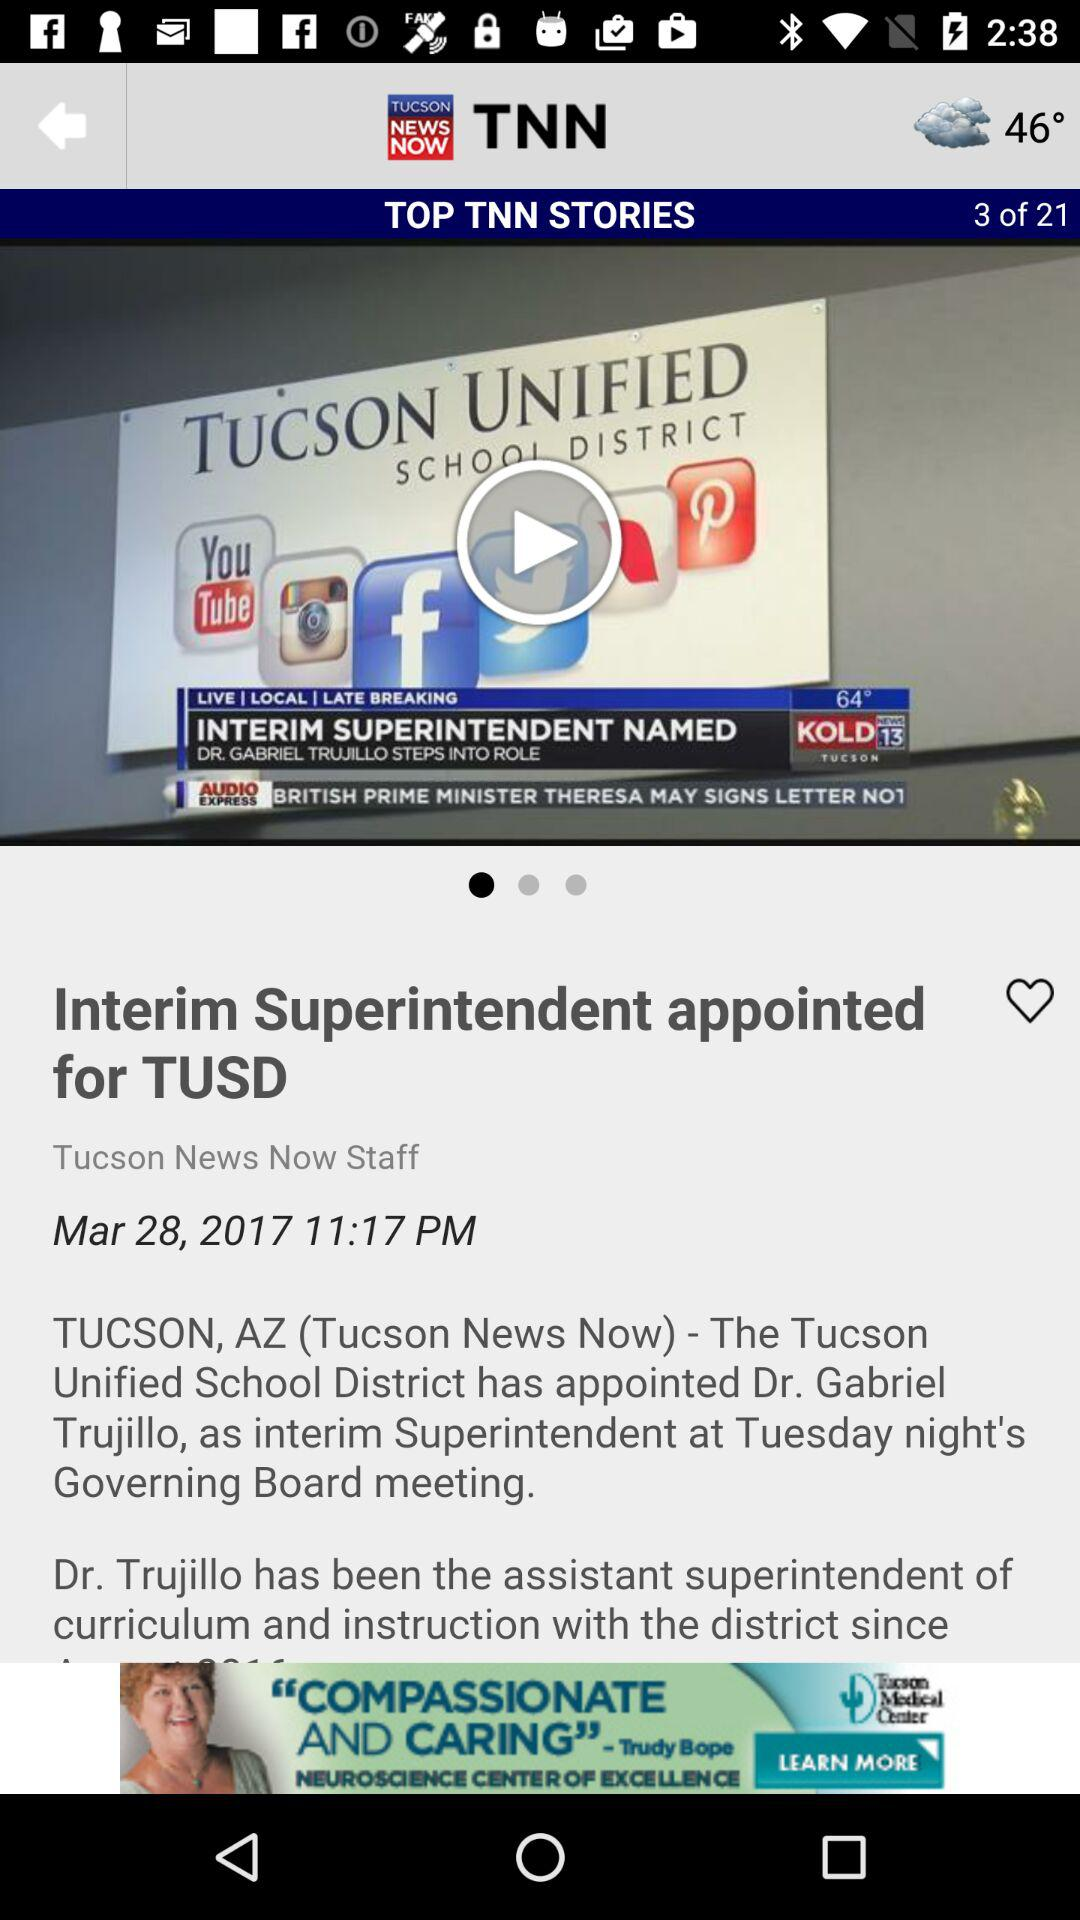What news is being shown right now? The news shown is "Interim Superintendent appointed for TUSD". 